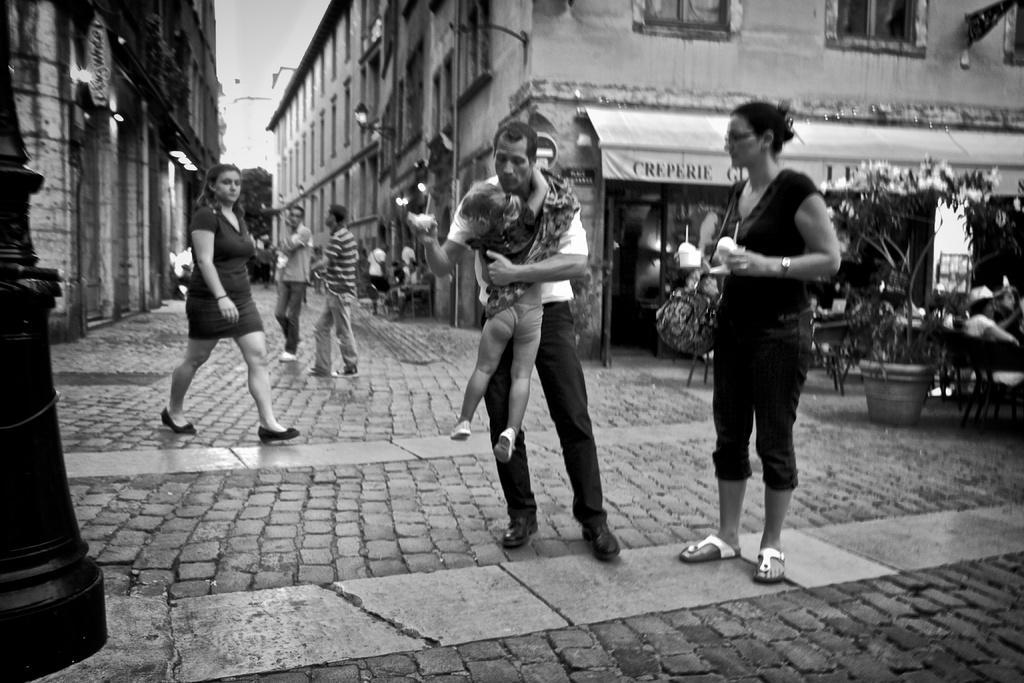Describe this image in one or two sentences. In this picture I can see people standing on the surface. I can see the flower pot on the right side. I can see the buildings in the background. I can see the lights on the wall. 